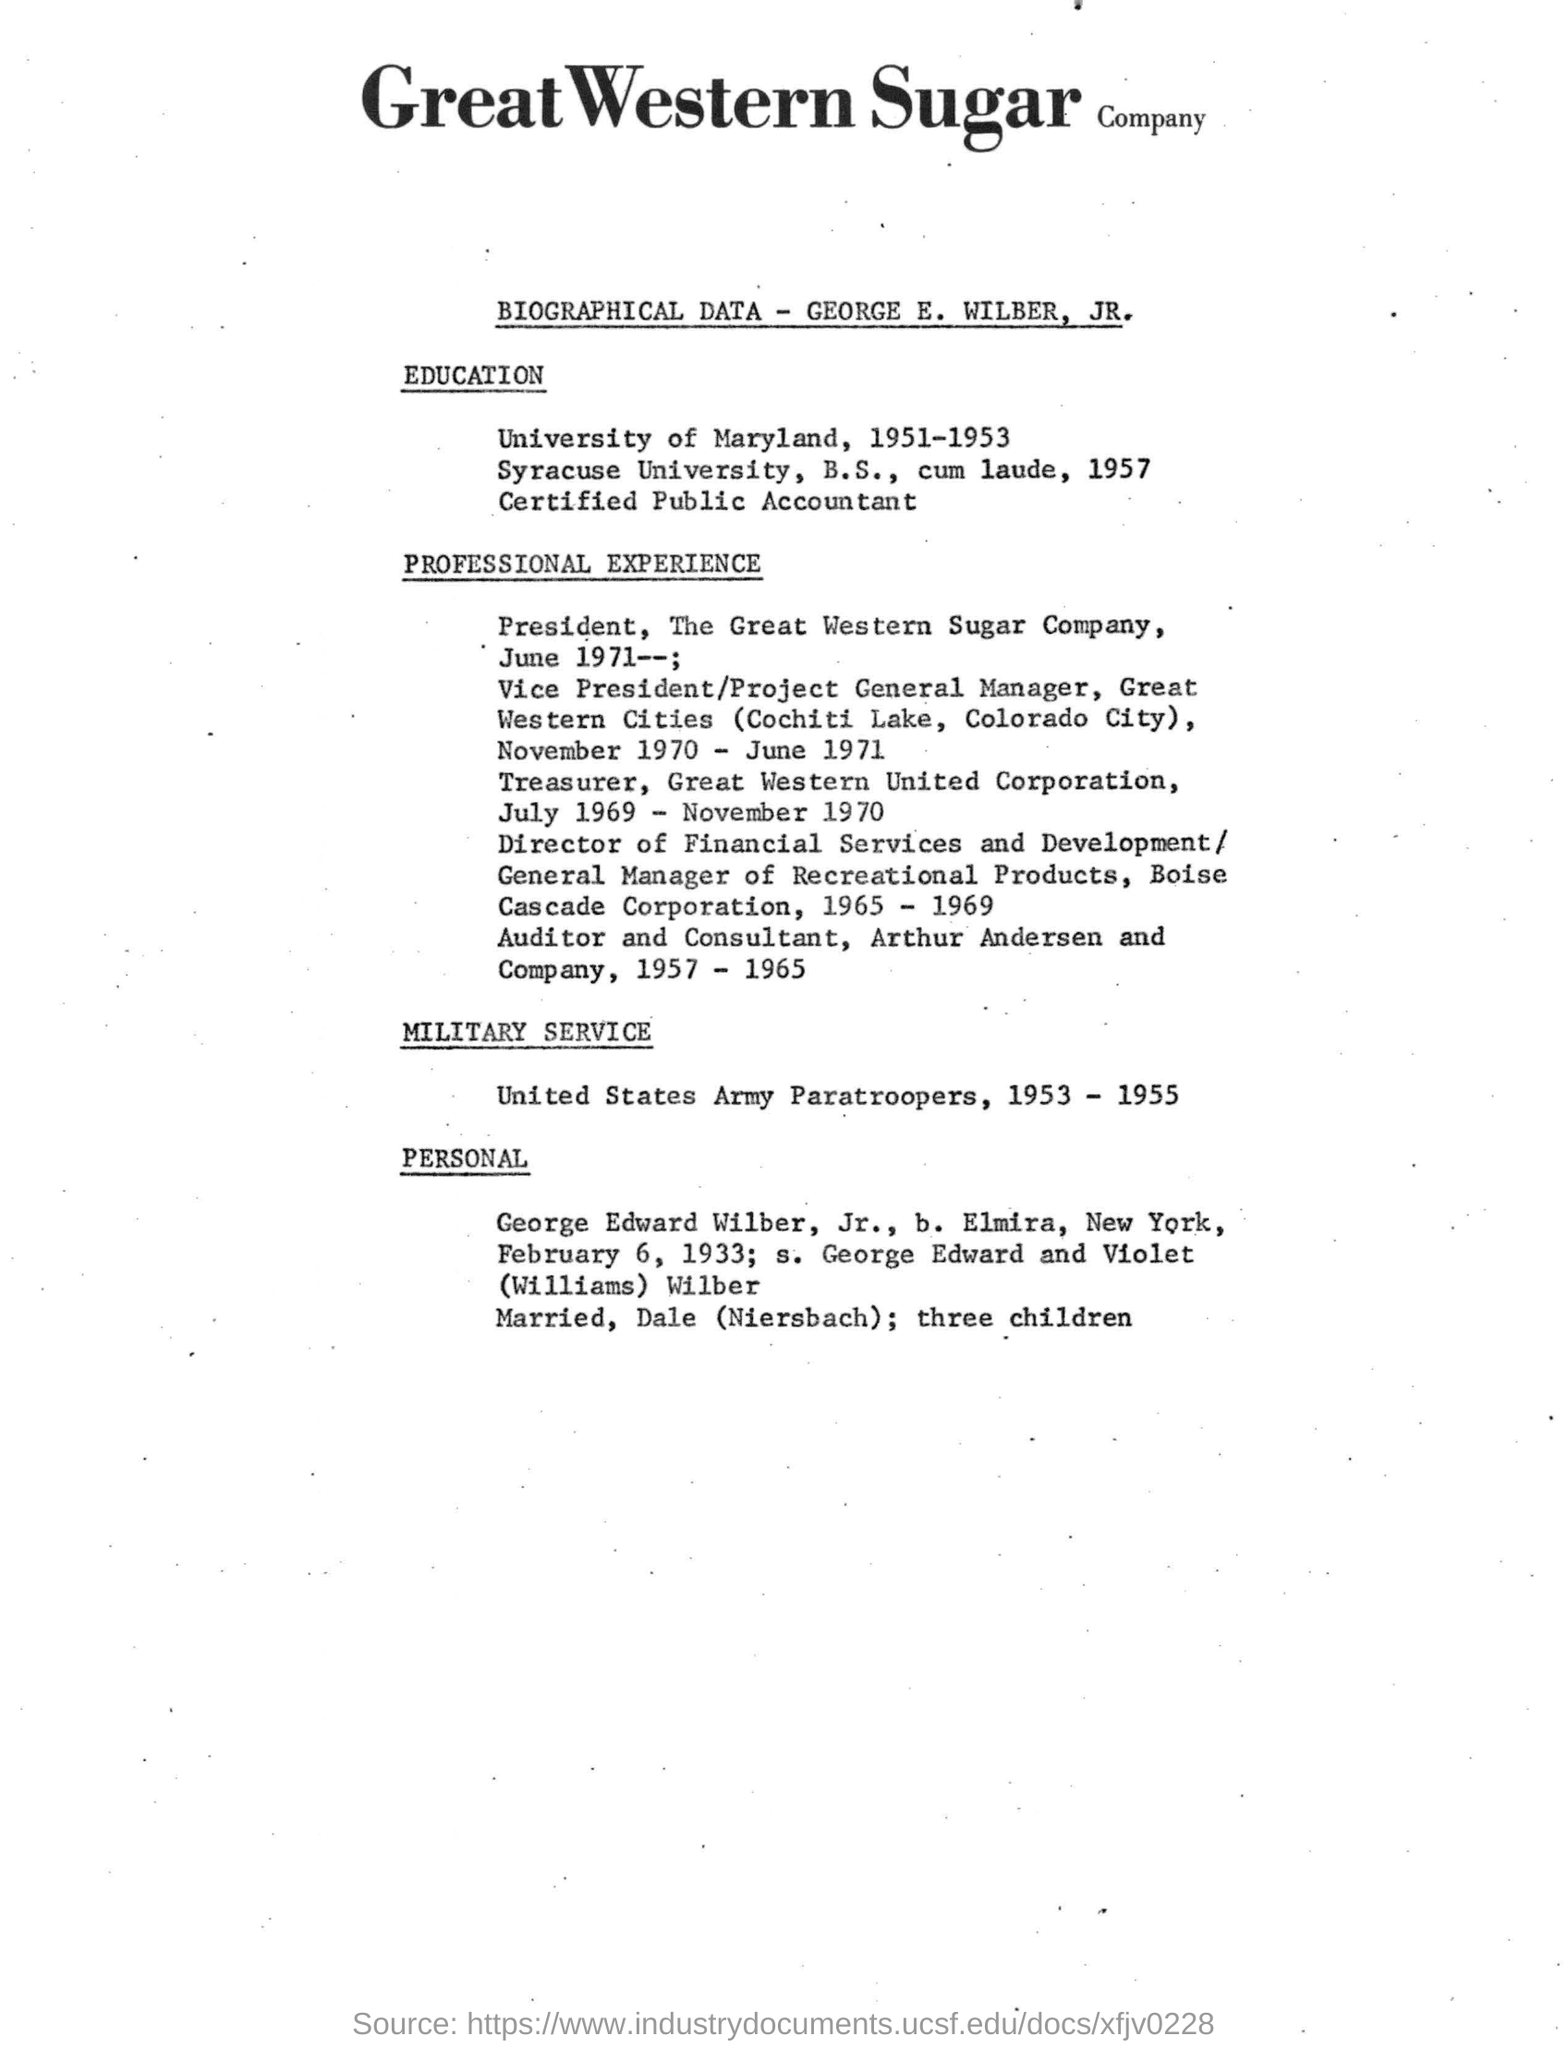Whose biographical data is mentioned?
Offer a very short reply. George E. Wilber, Jr. Where was the Great Western Cities located?
Provide a short and direct response. Cochiti Lake, Colorado City. In which company George worked as Auditor and Consultant?
Your response must be concise. Arthur Andersen and Company. 